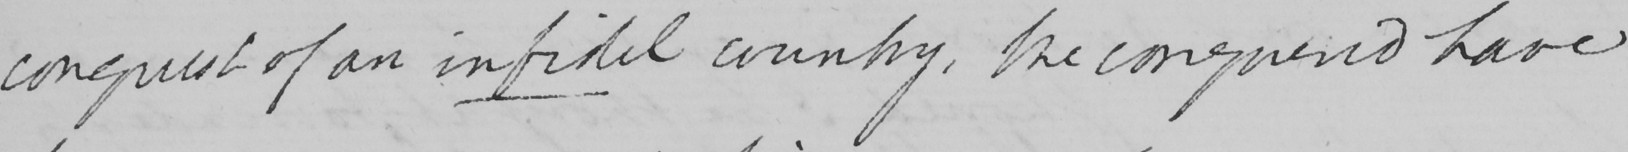What is written in this line of handwriting? conquest of an infidel country , the conquered have 